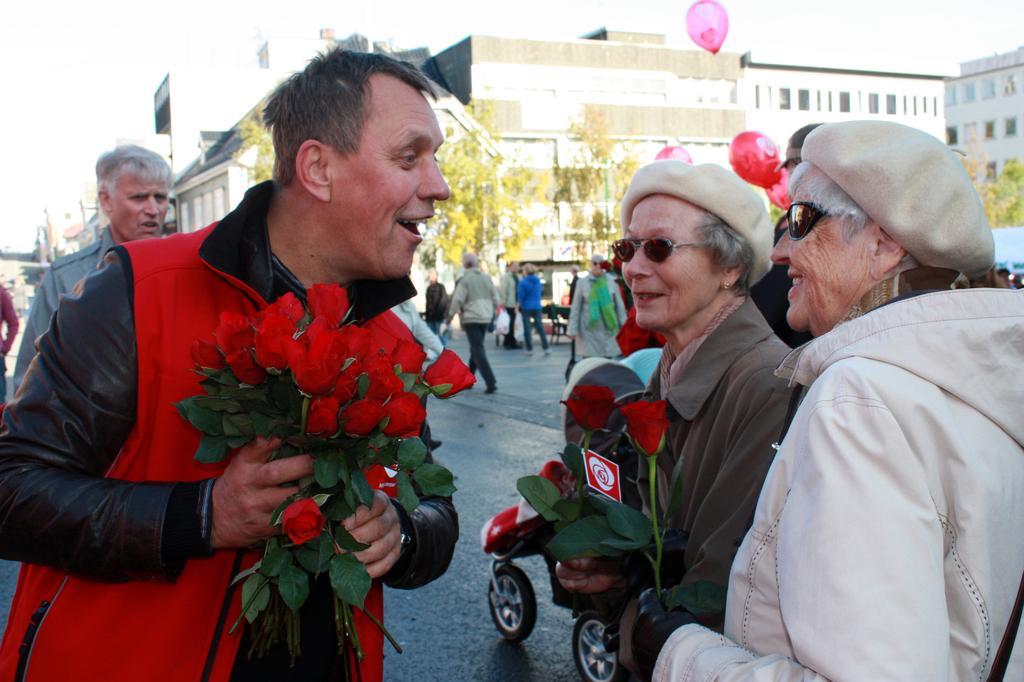In one or two sentences, can you explain what this image depicts? In this image on the road there are many people. In the foreground a man wearing red and black jacket is holding bunch of roses. In front of them there are two old ladies. They are wearing caps and sunglasses. In the background people are walking on the road. There are trees and buildings. There is a balloon in the air. 